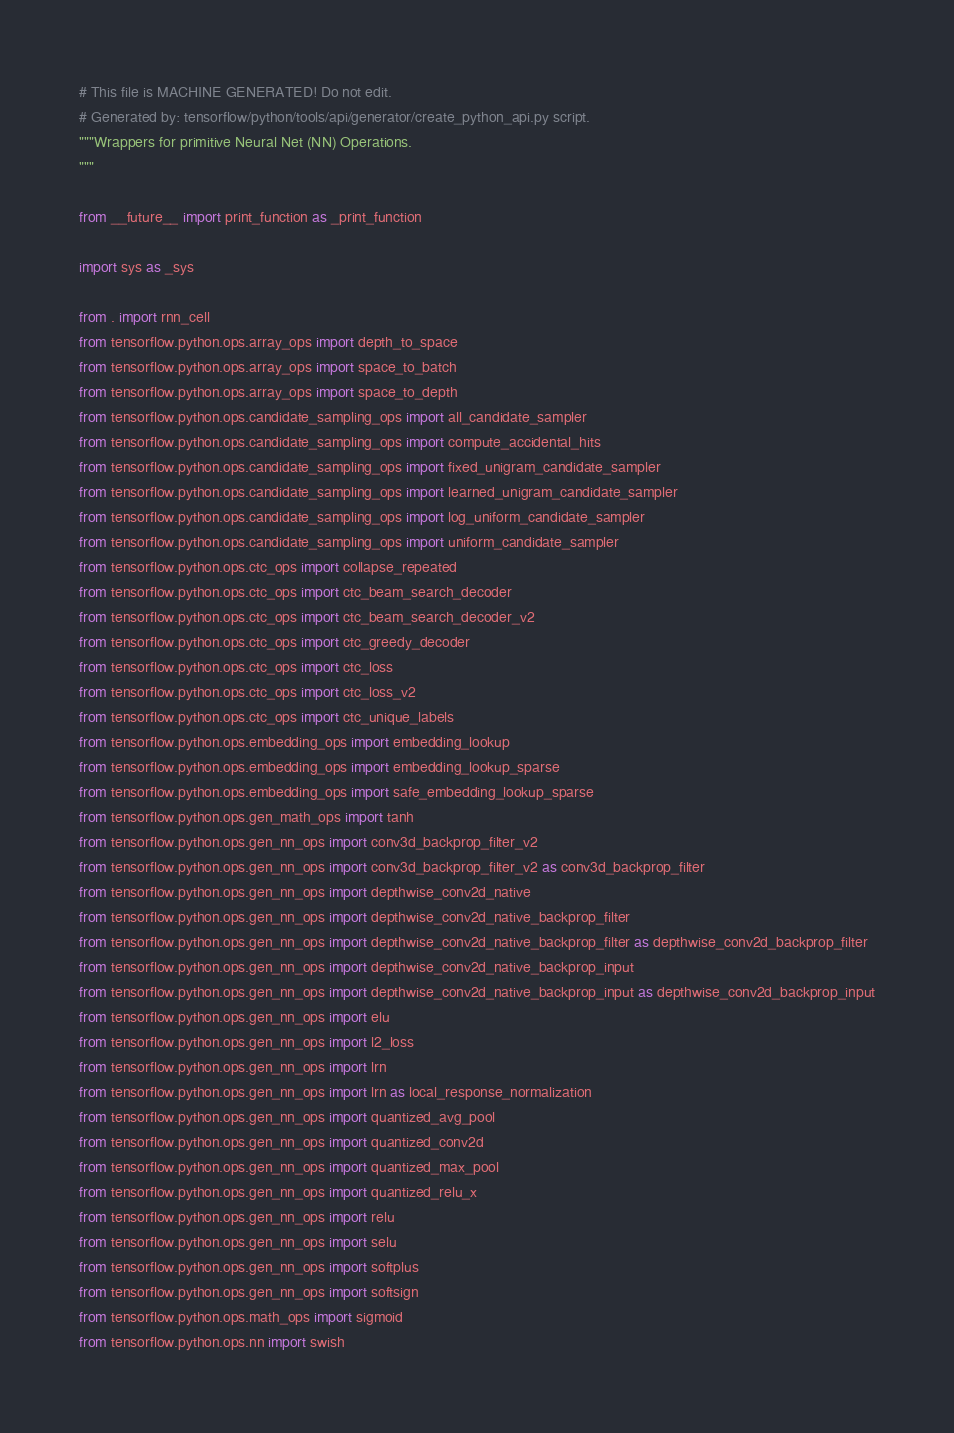<code> <loc_0><loc_0><loc_500><loc_500><_Python_># This file is MACHINE GENERATED! Do not edit.
# Generated by: tensorflow/python/tools/api/generator/create_python_api.py script.
"""Wrappers for primitive Neural Net (NN) Operations.
"""

from __future__ import print_function as _print_function

import sys as _sys

from . import rnn_cell
from tensorflow.python.ops.array_ops import depth_to_space
from tensorflow.python.ops.array_ops import space_to_batch
from tensorflow.python.ops.array_ops import space_to_depth
from tensorflow.python.ops.candidate_sampling_ops import all_candidate_sampler
from tensorflow.python.ops.candidate_sampling_ops import compute_accidental_hits
from tensorflow.python.ops.candidate_sampling_ops import fixed_unigram_candidate_sampler
from tensorflow.python.ops.candidate_sampling_ops import learned_unigram_candidate_sampler
from tensorflow.python.ops.candidate_sampling_ops import log_uniform_candidate_sampler
from tensorflow.python.ops.candidate_sampling_ops import uniform_candidate_sampler
from tensorflow.python.ops.ctc_ops import collapse_repeated
from tensorflow.python.ops.ctc_ops import ctc_beam_search_decoder
from tensorflow.python.ops.ctc_ops import ctc_beam_search_decoder_v2
from tensorflow.python.ops.ctc_ops import ctc_greedy_decoder
from tensorflow.python.ops.ctc_ops import ctc_loss
from tensorflow.python.ops.ctc_ops import ctc_loss_v2
from tensorflow.python.ops.ctc_ops import ctc_unique_labels
from tensorflow.python.ops.embedding_ops import embedding_lookup
from tensorflow.python.ops.embedding_ops import embedding_lookup_sparse
from tensorflow.python.ops.embedding_ops import safe_embedding_lookup_sparse
from tensorflow.python.ops.gen_math_ops import tanh
from tensorflow.python.ops.gen_nn_ops import conv3d_backprop_filter_v2
from tensorflow.python.ops.gen_nn_ops import conv3d_backprop_filter_v2 as conv3d_backprop_filter
from tensorflow.python.ops.gen_nn_ops import depthwise_conv2d_native
from tensorflow.python.ops.gen_nn_ops import depthwise_conv2d_native_backprop_filter
from tensorflow.python.ops.gen_nn_ops import depthwise_conv2d_native_backprop_filter as depthwise_conv2d_backprop_filter
from tensorflow.python.ops.gen_nn_ops import depthwise_conv2d_native_backprop_input
from tensorflow.python.ops.gen_nn_ops import depthwise_conv2d_native_backprop_input as depthwise_conv2d_backprop_input
from tensorflow.python.ops.gen_nn_ops import elu
from tensorflow.python.ops.gen_nn_ops import l2_loss
from tensorflow.python.ops.gen_nn_ops import lrn
from tensorflow.python.ops.gen_nn_ops import lrn as local_response_normalization
from tensorflow.python.ops.gen_nn_ops import quantized_avg_pool
from tensorflow.python.ops.gen_nn_ops import quantized_conv2d
from tensorflow.python.ops.gen_nn_ops import quantized_max_pool
from tensorflow.python.ops.gen_nn_ops import quantized_relu_x
from tensorflow.python.ops.gen_nn_ops import relu
from tensorflow.python.ops.gen_nn_ops import selu
from tensorflow.python.ops.gen_nn_ops import softplus
from tensorflow.python.ops.gen_nn_ops import softsign
from tensorflow.python.ops.math_ops import sigmoid
from tensorflow.python.ops.nn import swish</code> 